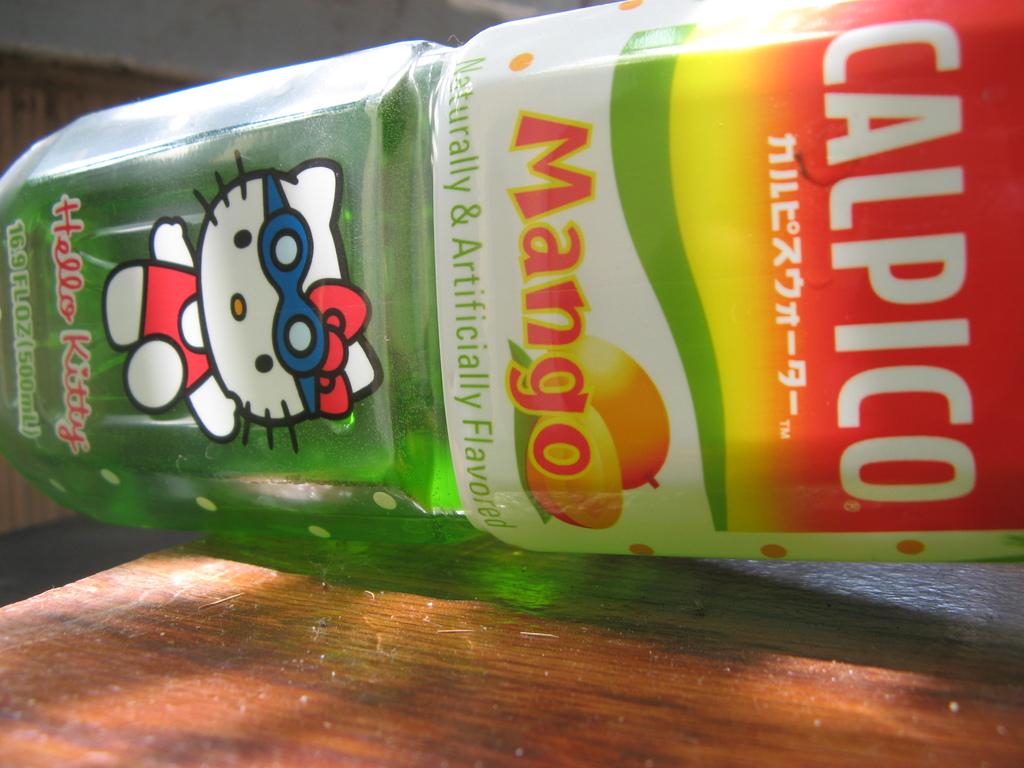What flavor is this drink?
Make the answer very short. Mango. Who is the mascot on this?
Your answer should be very brief. Hello kitty. 